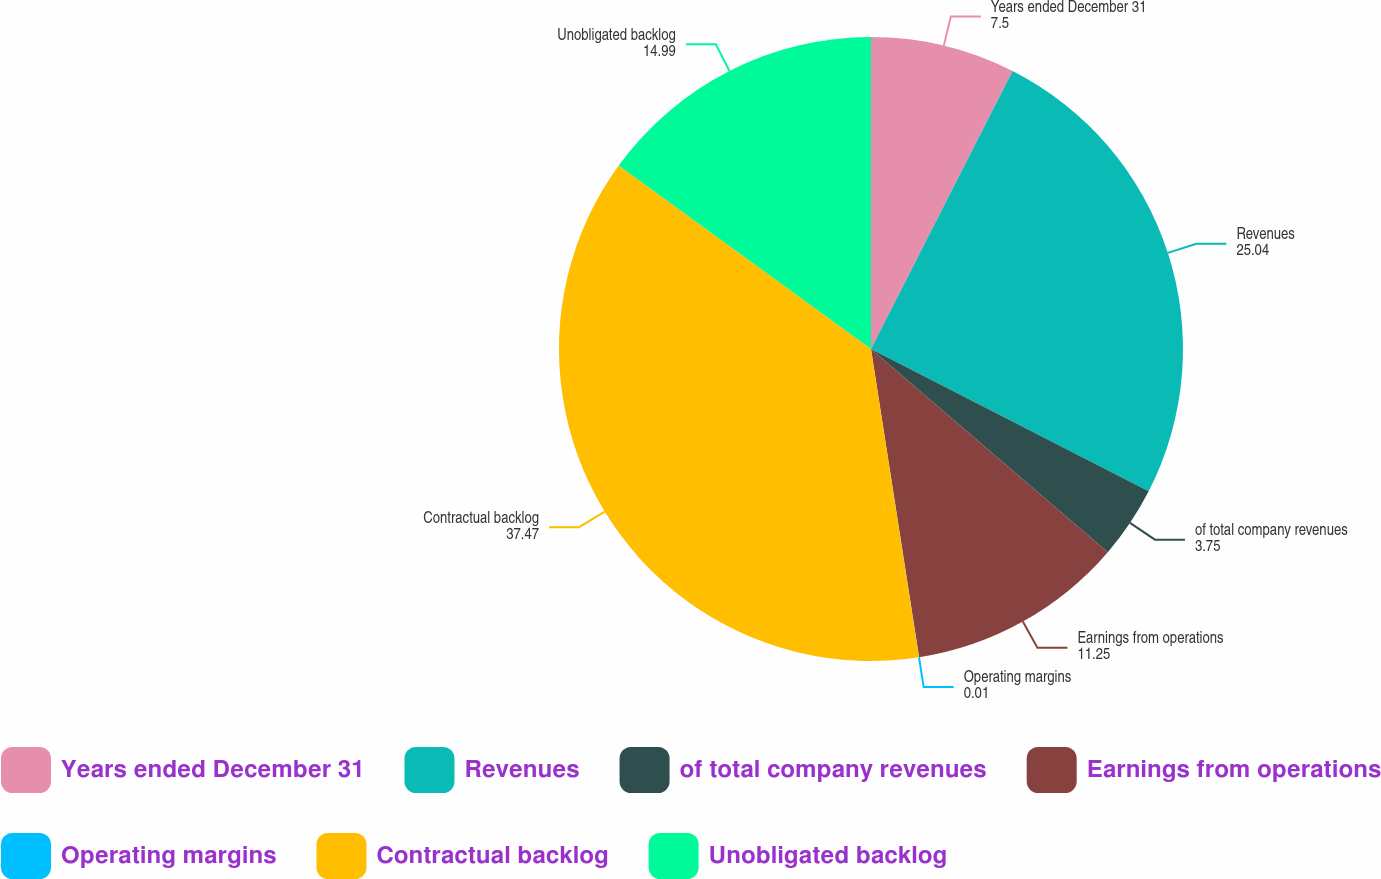Convert chart to OTSL. <chart><loc_0><loc_0><loc_500><loc_500><pie_chart><fcel>Years ended December 31<fcel>Revenues<fcel>of total company revenues<fcel>Earnings from operations<fcel>Operating margins<fcel>Contractual backlog<fcel>Unobligated backlog<nl><fcel>7.5%<fcel>25.04%<fcel>3.75%<fcel>11.25%<fcel>0.01%<fcel>37.47%<fcel>14.99%<nl></chart> 